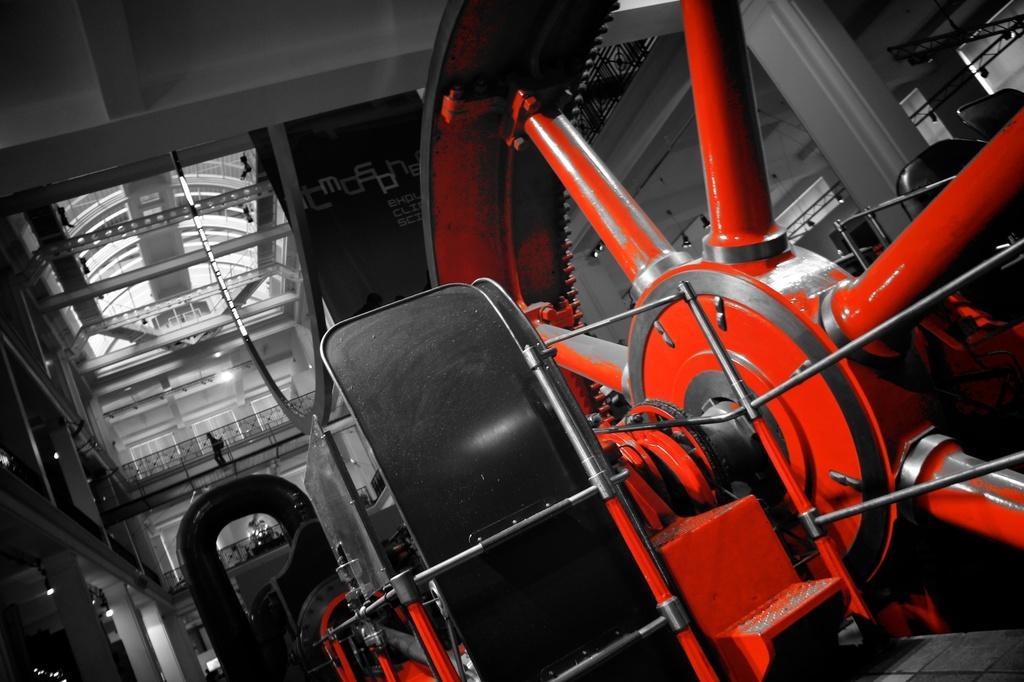Please provide a concise description of this image. This is an inside view. On the right side there is a wheel and I can see few machine tools. On the left side there are few pillars. In the background, I can see the walls and windows and there is a person behind the railing. 